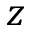Convert formula to latex. <formula><loc_0><loc_0><loc_500><loc_500>z</formula> 